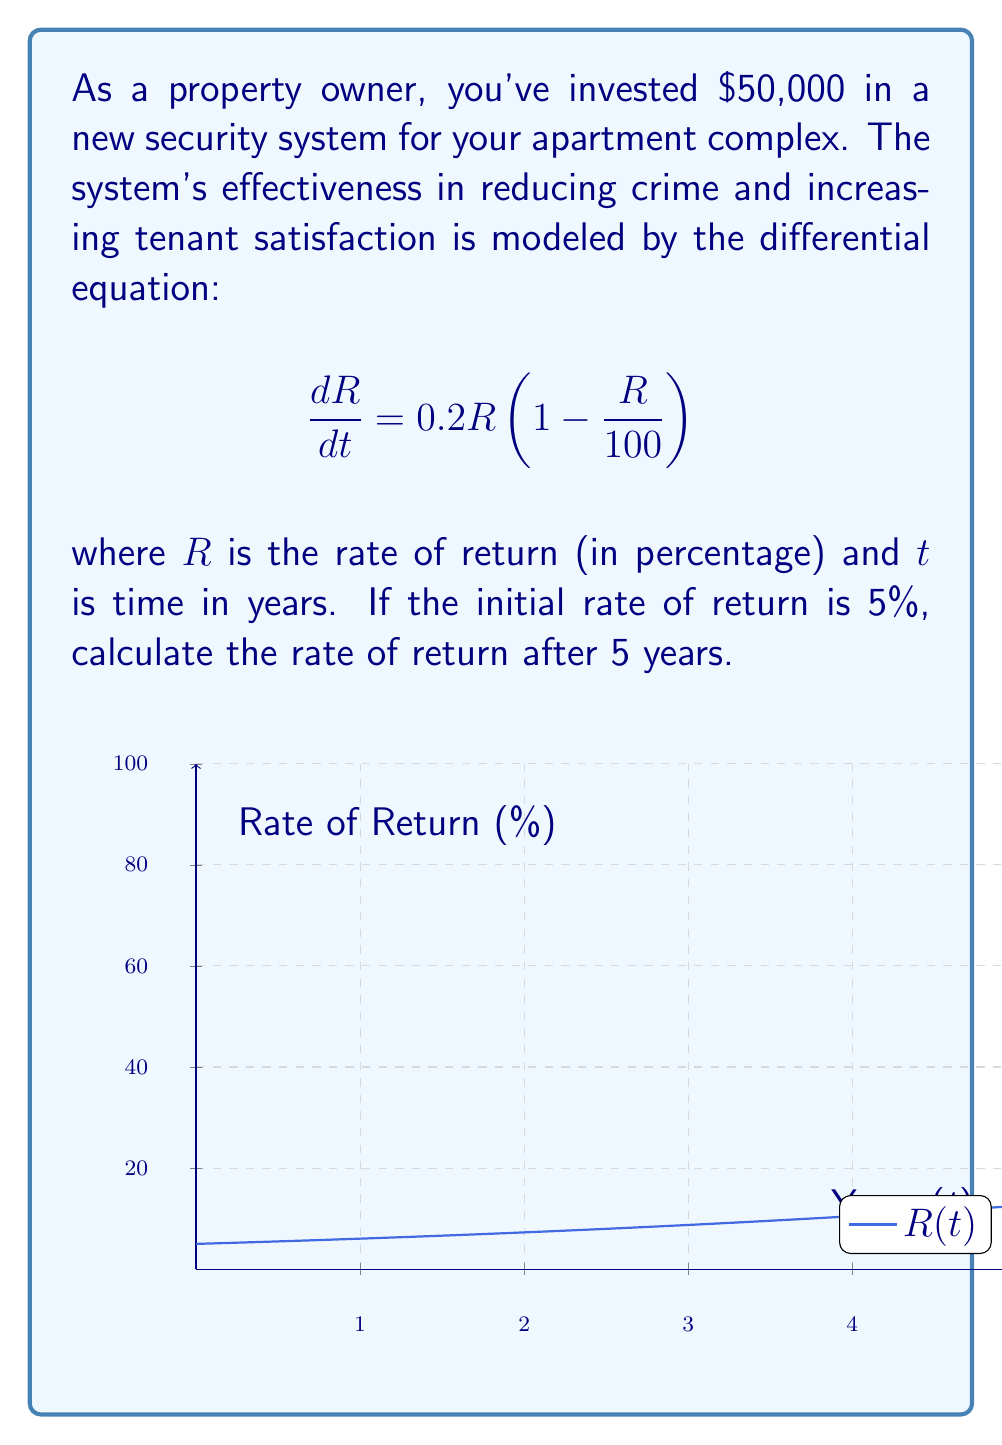Can you solve this math problem? To solve this problem, we need to follow these steps:

1) The given differential equation is a logistic growth model:
   $$\frac{dR}{dt} = 0.2R(1 - \frac{R}{100})$$

2) The general solution for this type of equation is:
   $$R(t) = \frac{K}{1 + Ce^{-rt}}$$
   where $K$ is the carrying capacity (100% in this case), $r$ is the growth rate (0.2 in this case), and $C$ is a constant we need to determine.

3) We're given the initial condition: $R(0) = 5$. Let's use this to find $C$:
   $$5 = \frac{100}{1 + C}$$
   $$1 + C = \frac{100}{5} = 20$$
   $$C = 19$$

4) Now we have our specific solution:
   $$R(t) = \frac{100}{1 + 19e^{-0.2t}}$$

5) To find $R(5)$, we simply plug in $t = 5$:
   $$R(5) = \frac{100}{1 + 19e^{-0.2(5)}}$$
   $$= \frac{100}{1 + 19e^{-1}}$$
   $$\approx 23.86$$

Therefore, after 5 years, the rate of return will be approximately 23.86%.
Answer: $23.86\%$ 